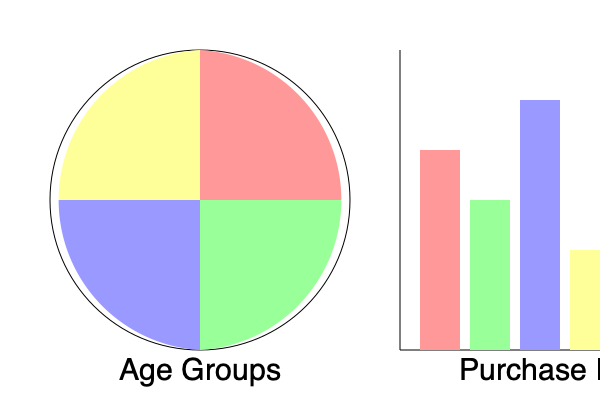As a high-end retail store owner, you've collected data on your customer base. The pie chart represents the age distribution of your customers, while the bar graph shows the purchase frequency for each age group. Based on this information, which age group should you target for a loyalty program to maximize its impact on sales, and why? To determine which age group to target for a loyalty program, we need to analyze both the size of the age group and their purchase frequency. Let's break down the analysis step-by-step:

1. Analyze the pie chart (age distribution):
   - Red segment (top right): Approximately 35% of customers
   - Green segment (bottom right): Approximately 25% of customers
   - Blue segment (bottom left): Approximately 30% of customers
   - Yellow segment (top left): Approximately 10% of customers

2. Analyze the bar graph (purchase frequency):
   - Red bar (leftmost): Medium-high frequency
   - Green bar (second from left): Medium frequency
   - Blue bar (third from left): Highest frequency
   - Yellow bar (rightmost): Lowest frequency

3. Combine the information:
   - Red group: Large customer base (35%) with medium-high purchase frequency
   - Green group: Moderate customer base (25%) with medium purchase frequency
   - Blue group: Large customer base (30%) with the highest purchase frequency
   - Yellow group: Small customer base (10%) with the lowest purchase frequency

4. Evaluate the impact:
   - The blue group represents a large portion of the customer base (30%) and has the highest purchase frequency, making it the most valuable segment.
   - Targeting this group with a loyalty program would likely have the greatest impact on sales, as it would incentivize the most frequent buyers to purchase even more.
   - The red group could be a secondary target, as it has a slightly larger customer base but lower purchase frequency.

5. Consider long-term strategy:
   - While the blue group is the best immediate target, consider developing strategies to increase purchase frequency in other groups, especially the large red segment.
Answer: Target the blue segment (30% of customers with highest purchase frequency) for maximum impact on sales. 